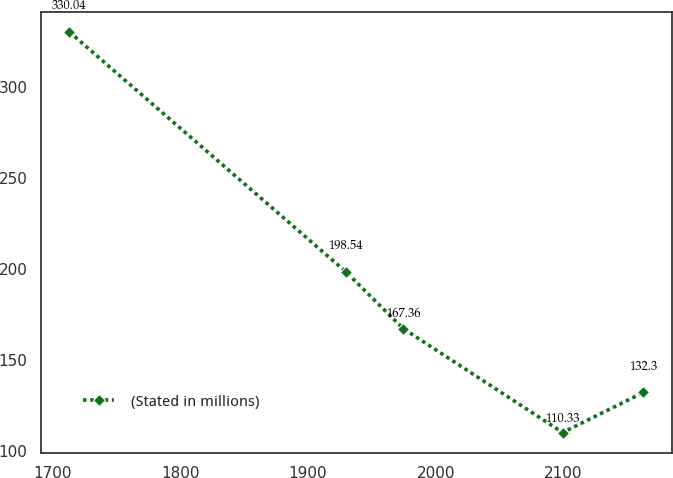<chart> <loc_0><loc_0><loc_500><loc_500><line_chart><ecel><fcel>(Stated in millions)<nl><fcel>1713.24<fcel>330.04<nl><fcel>1929.59<fcel>198.54<nl><fcel>1974.53<fcel>167.36<nl><fcel>2099.32<fcel>110.33<nl><fcel>2162.6<fcel>132.3<nl></chart> 